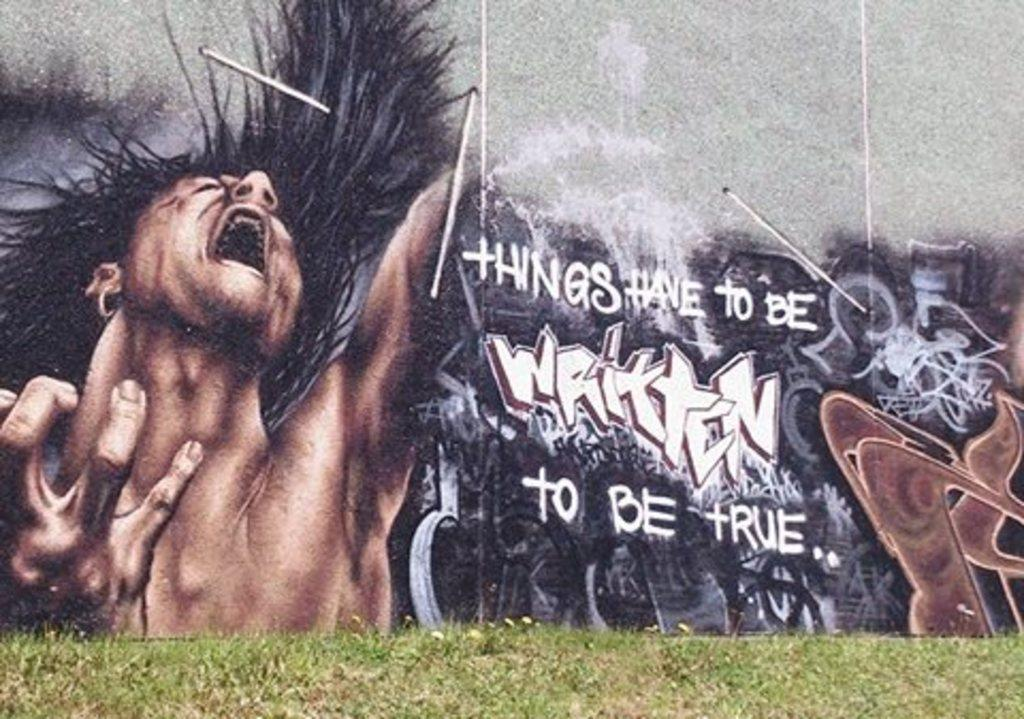Provide a one-sentence caption for the provided image. A wall has graffiti and the text 'things have to be written to be true'. 